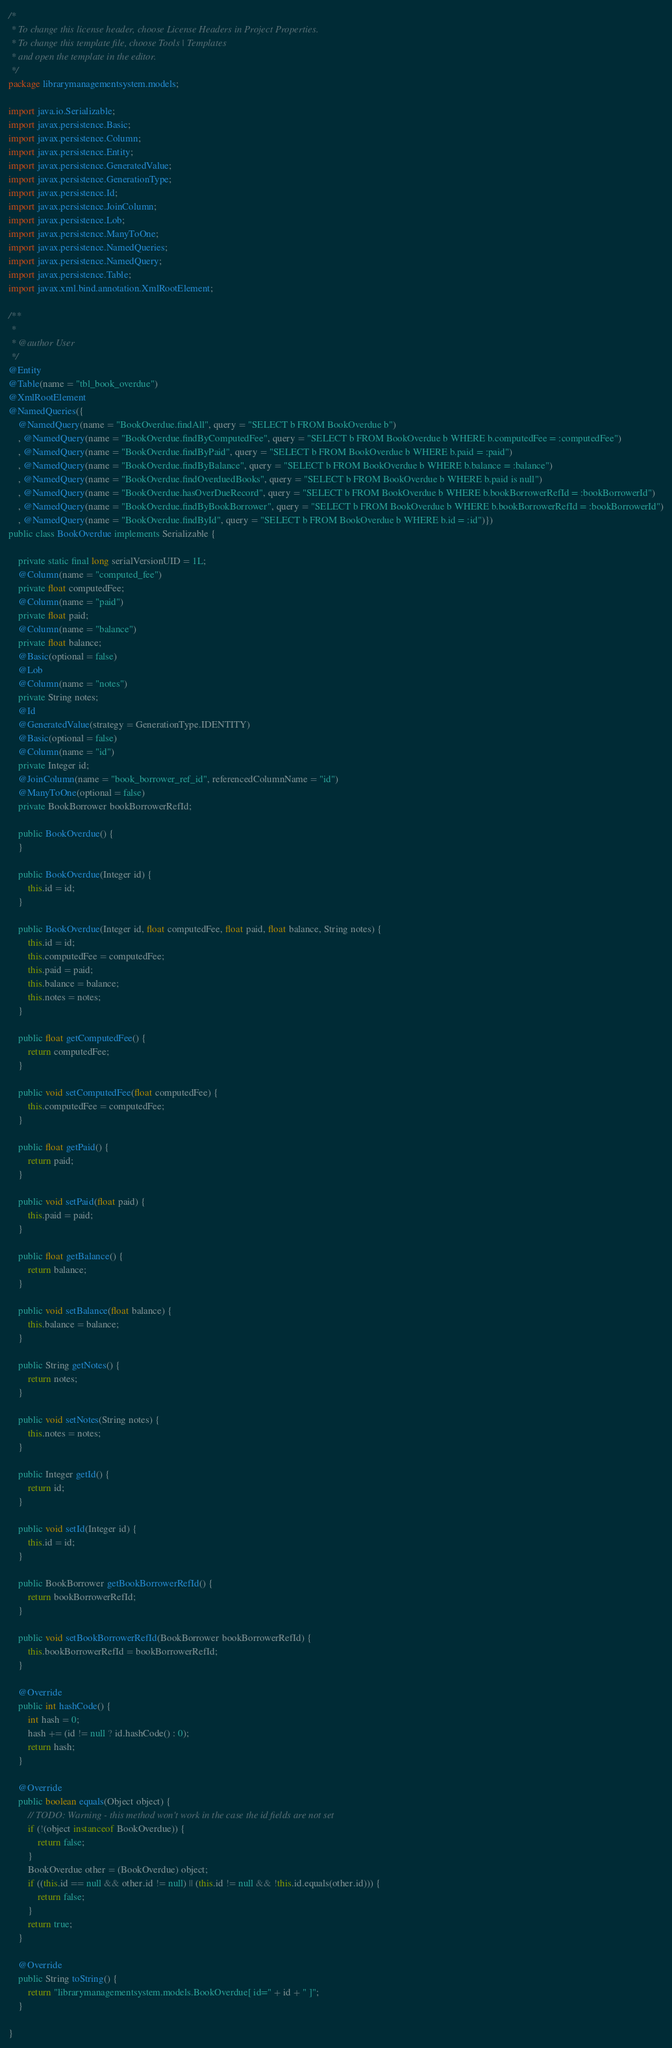<code> <loc_0><loc_0><loc_500><loc_500><_Java_>/*
 * To change this license header, choose License Headers in Project Properties.
 * To change this template file, choose Tools | Templates
 * and open the template in the editor.
 */
package librarymanagementsystem.models;

import java.io.Serializable;
import javax.persistence.Basic;
import javax.persistence.Column;
import javax.persistence.Entity;
import javax.persistence.GeneratedValue;
import javax.persistence.GenerationType;
import javax.persistence.Id;
import javax.persistence.JoinColumn;
import javax.persistence.Lob;
import javax.persistence.ManyToOne;
import javax.persistence.NamedQueries;
import javax.persistence.NamedQuery;
import javax.persistence.Table;
import javax.xml.bind.annotation.XmlRootElement;

/**
 *
 * @author User
 */
@Entity
@Table(name = "tbl_book_overdue")
@XmlRootElement
@NamedQueries({
    @NamedQuery(name = "BookOverdue.findAll", query = "SELECT b FROM BookOverdue b")
    , @NamedQuery(name = "BookOverdue.findByComputedFee", query = "SELECT b FROM BookOverdue b WHERE b.computedFee = :computedFee")
    , @NamedQuery(name = "BookOverdue.findByPaid", query = "SELECT b FROM BookOverdue b WHERE b.paid = :paid")
    , @NamedQuery(name = "BookOverdue.findByBalance", query = "SELECT b FROM BookOverdue b WHERE b.balance = :balance")
    , @NamedQuery(name = "BookOverdue.findOverduedBooks", query = "SELECT b FROM BookOverdue b WHERE b.paid is null")
    , @NamedQuery(name = "BookOverdue.hasOverDueRecord", query = "SELECT b FROM BookOverdue b WHERE b.bookBorrowerRefId = :bookBorrowerId")
    , @NamedQuery(name = "BookOverdue.findByBookBorrower", query = "SELECT b FROM BookOverdue b WHERE b.bookBorrowerRefId = :bookBorrowerId")
    , @NamedQuery(name = "BookOverdue.findById", query = "SELECT b FROM BookOverdue b WHERE b.id = :id")})
public class BookOverdue implements Serializable {

    private static final long serialVersionUID = 1L;
    @Column(name = "computed_fee")
    private float computedFee;
    @Column(name = "paid")
    private float paid;
    @Column(name = "balance")
    private float balance;
    @Basic(optional = false)
    @Lob
    @Column(name = "notes")
    private String notes;
    @Id
    @GeneratedValue(strategy = GenerationType.IDENTITY)
    @Basic(optional = false)
    @Column(name = "id")
    private Integer id;
    @JoinColumn(name = "book_borrower_ref_id", referencedColumnName = "id")
    @ManyToOne(optional = false)
    private BookBorrower bookBorrowerRefId;

    public BookOverdue() {
    }

    public BookOverdue(Integer id) {
        this.id = id;
    }

    public BookOverdue(Integer id, float computedFee, float paid, float balance, String notes) {
        this.id = id;
        this.computedFee = computedFee;
        this.paid = paid;
        this.balance = balance;
        this.notes = notes;
    }

    public float getComputedFee() {
        return computedFee;
    }

    public void setComputedFee(float computedFee) {
        this.computedFee = computedFee;
    }

    public float getPaid() {
        return paid;
    }

    public void setPaid(float paid) {
        this.paid = paid;
    }

    public float getBalance() {
        return balance;
    }

    public void setBalance(float balance) {
        this.balance = balance;
    }

    public String getNotes() {
        return notes;
    }

    public void setNotes(String notes) {
        this.notes = notes;
    }

    public Integer getId() {
        return id;
    }

    public void setId(Integer id) {
        this.id = id;
    }

    public BookBorrower getBookBorrowerRefId() {
        return bookBorrowerRefId;
    }

    public void setBookBorrowerRefId(BookBorrower bookBorrowerRefId) {
        this.bookBorrowerRefId = bookBorrowerRefId;
    }

    @Override
    public int hashCode() {
        int hash = 0;
        hash += (id != null ? id.hashCode() : 0);
        return hash;
    }

    @Override
    public boolean equals(Object object) {
        // TODO: Warning - this method won't work in the case the id fields are not set
        if (!(object instanceof BookOverdue)) {
            return false;
        }
        BookOverdue other = (BookOverdue) object;
        if ((this.id == null && other.id != null) || (this.id != null && !this.id.equals(other.id))) {
            return false;
        }
        return true;
    }

    @Override
    public String toString() {
        return "librarymanagementsystem.models.BookOverdue[ id=" + id + " ]";
    }
    
}
</code> 